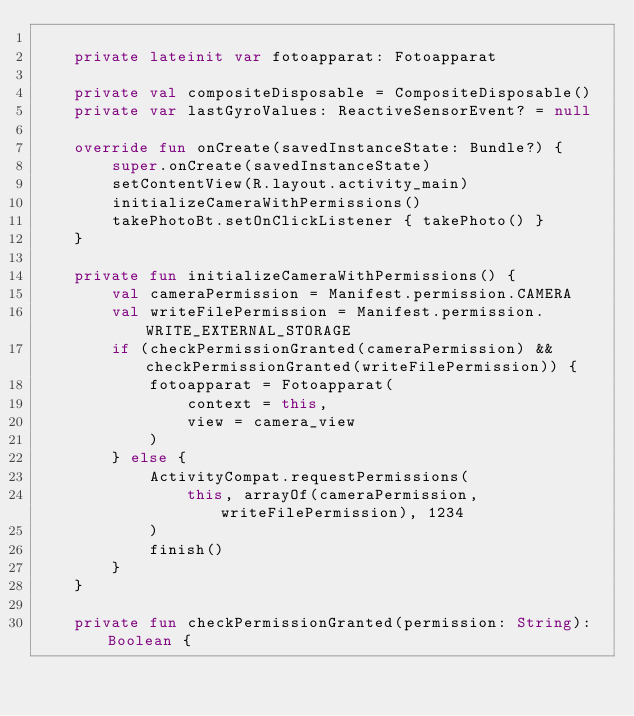Convert code to text. <code><loc_0><loc_0><loc_500><loc_500><_Kotlin_>
    private lateinit var fotoapparat: Fotoapparat

    private val compositeDisposable = CompositeDisposable()
    private var lastGyroValues: ReactiveSensorEvent? = null

    override fun onCreate(savedInstanceState: Bundle?) {
        super.onCreate(savedInstanceState)
        setContentView(R.layout.activity_main)
        initializeCameraWithPermissions()
        takePhotoBt.setOnClickListener { takePhoto() }
    }

    private fun initializeCameraWithPermissions() {
        val cameraPermission = Manifest.permission.CAMERA
        val writeFilePermission = Manifest.permission.WRITE_EXTERNAL_STORAGE
        if (checkPermissionGranted(cameraPermission) && checkPermissionGranted(writeFilePermission)) {
            fotoapparat = Fotoapparat(
                context = this,
                view = camera_view
            )
        } else {
            ActivityCompat.requestPermissions(
                this, arrayOf(cameraPermission, writeFilePermission), 1234
            )
            finish()
        }
    }

    private fun checkPermissionGranted(permission: String): Boolean {</code> 